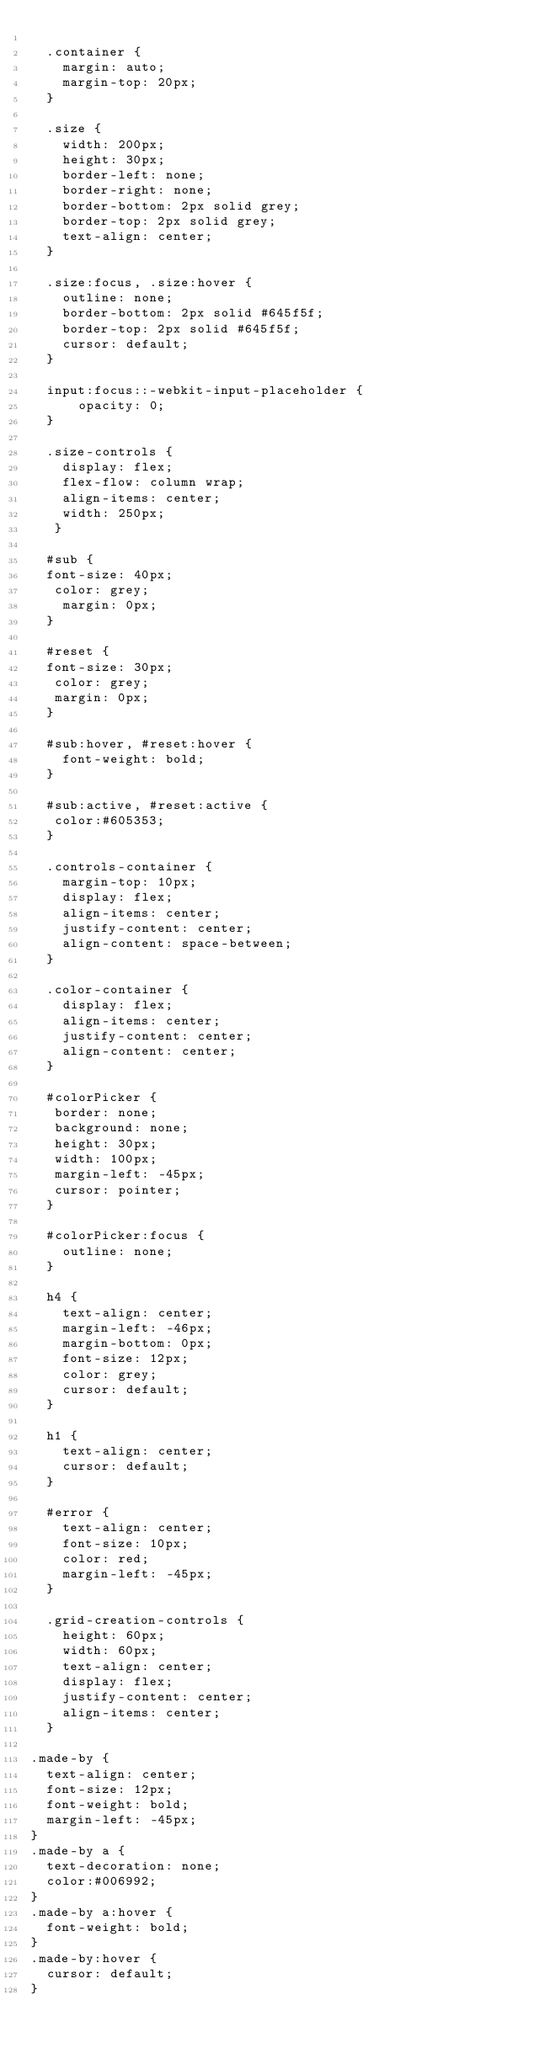<code> <loc_0><loc_0><loc_500><loc_500><_CSS_>
  .container {
    margin: auto;
    margin-top: 20px;
  }

  .size {
    width: 200px;
    height: 30px;
    border-left: none;
    border-right: none;
    border-bottom: 2px solid grey;
    border-top: 2px solid grey;
    text-align: center;
  }

  .size:focus, .size:hover {
    outline: none;
    border-bottom: 2px solid #645f5f;
    border-top: 2px solid #645f5f;
    cursor: default;
  }

  input:focus::-webkit-input-placeholder {
      opacity: 0;
  }

  .size-controls {
    display: flex;
    flex-flow: column wrap;
    align-items: center;
    width: 250px;
   }

  #sub {
  font-size: 40px;
   color: grey;
    margin: 0px;
  }

  #reset {
  font-size: 30px;
   color: grey;
   margin: 0px;
  }

  #sub:hover, #reset:hover {
    font-weight: bold;
  }

  #sub:active, #reset:active {
   color:#605353;
  }

  .controls-container {
    margin-top: 10px;
    display: flex;
    align-items: center;
    justify-content: center;
    align-content: space-between;
  }

  .color-container {
    display: flex;
    align-items: center;
    justify-content: center;
    align-content: center;
  }

  #colorPicker {
   border: none;
   background: none;
   height: 30px;
   width: 100px;
   margin-left: -45px;
   cursor: pointer;
  }

  #colorPicker:focus {
    outline: none;
  }

  h4 {
    text-align: center;
    margin-left: -46px;
    margin-bottom: 0px;
    font-size: 12px;
    color: grey;
    cursor: default;
  }

  h1 {
    text-align: center;
    cursor: default;
  }

  #error {
    text-align: center;
    font-size: 10px;
    color: red;
    margin-left: -45px;
  }

  .grid-creation-controls {
    height: 60px;
    width: 60px;
    text-align: center;
    display: flex;
    justify-content: center;
    align-items: center;
  }

.made-by {
  text-align: center;
  font-size: 12px;
  font-weight: bold;
  margin-left: -45px;
}
.made-by a {
  text-decoration: none;
  color:#006992;
}
.made-by a:hover {
  font-weight: bold;
}
.made-by:hover {
  cursor: default;
}

</code> 